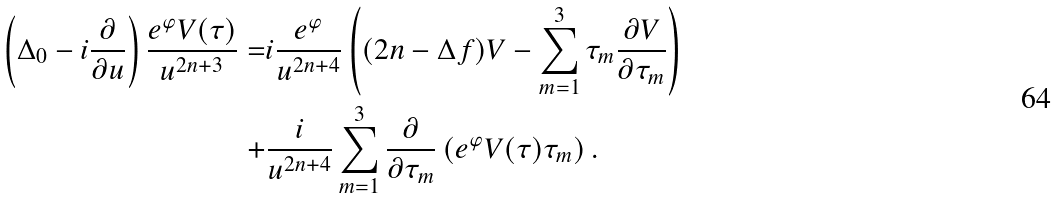<formula> <loc_0><loc_0><loc_500><loc_500>\left ( \Delta _ { 0 } - i \frac { \partial } { \partial u } \right ) \frac { e ^ { \varphi } V ( \tau ) } { u ^ { 2 n + 3 } } = & i \frac { e ^ { \varphi } } { u ^ { 2 n + 4 } } \left ( ( 2 n - \Delta f ) V - \sum _ { m = 1 } ^ { 3 } \tau _ { m } \frac { \partial V } { \partial \tau _ { m } } \right ) \\ + & \frac { i } { u ^ { 2 n + 4 } } \sum _ { m = 1 } ^ { 3 } \frac { \partial } { \partial \tau _ { m } } \left ( e ^ { \varphi } V ( \tau ) \tau _ { m } \right ) .</formula> 